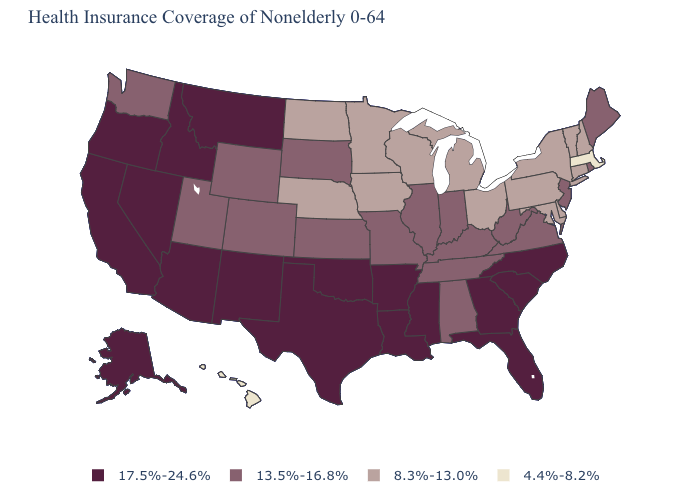Name the states that have a value in the range 17.5%-24.6%?
Give a very brief answer. Alaska, Arizona, Arkansas, California, Florida, Georgia, Idaho, Louisiana, Mississippi, Montana, Nevada, New Mexico, North Carolina, Oklahoma, Oregon, South Carolina, Texas. How many symbols are there in the legend?
Concise answer only. 4. What is the highest value in the MidWest ?
Answer briefly. 13.5%-16.8%. What is the value of Kentucky?
Keep it brief. 13.5%-16.8%. Which states hav the highest value in the MidWest?
Short answer required. Illinois, Indiana, Kansas, Missouri, South Dakota. Which states have the lowest value in the South?
Give a very brief answer. Delaware, Maryland. Which states have the highest value in the USA?
Give a very brief answer. Alaska, Arizona, Arkansas, California, Florida, Georgia, Idaho, Louisiana, Mississippi, Montana, Nevada, New Mexico, North Carolina, Oklahoma, Oregon, South Carolina, Texas. Among the states that border Nebraska , does Iowa have the highest value?
Concise answer only. No. Does Pennsylvania have a higher value than Missouri?
Answer briefly. No. Is the legend a continuous bar?
Answer briefly. No. Among the states that border Delaware , does Pennsylvania have the highest value?
Answer briefly. No. Name the states that have a value in the range 4.4%-8.2%?
Quick response, please. Hawaii, Massachusetts. What is the lowest value in states that border Colorado?
Keep it brief. 8.3%-13.0%. Among the states that border Idaho , which have the highest value?
Write a very short answer. Montana, Nevada, Oregon. What is the value of Florida?
Short answer required. 17.5%-24.6%. 